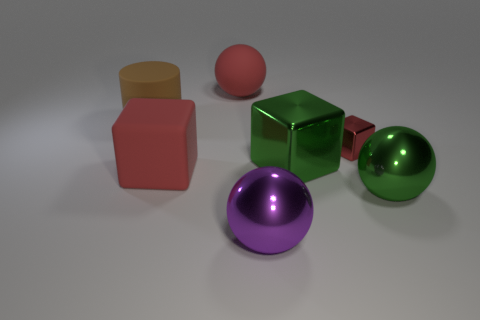Subtract all big metal spheres. How many spheres are left? 1 Add 3 small green matte cubes. How many objects exist? 10 Subtract all purple cylinders. How many red blocks are left? 2 Subtract all red cubes. How many cubes are left? 1 Subtract all blocks. How many objects are left? 4 Subtract all metallic spheres. Subtract all large matte cubes. How many objects are left? 4 Add 2 matte spheres. How many matte spheres are left? 3 Add 1 blue matte blocks. How many blue matte blocks exist? 1 Subtract 0 cyan cubes. How many objects are left? 7 Subtract all green blocks. Subtract all red cylinders. How many blocks are left? 2 